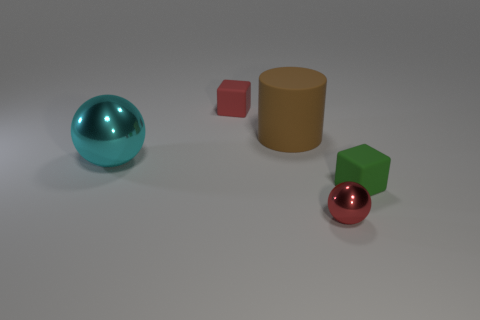Add 2 brown rubber things. How many objects exist? 7 Subtract all blocks. How many objects are left? 3 Subtract 0 red cylinders. How many objects are left? 5 Subtract all matte cylinders. Subtract all tiny red shiny balls. How many objects are left? 3 Add 2 big cyan metallic objects. How many big cyan metallic objects are left? 3 Add 1 tiny yellow cylinders. How many tiny yellow cylinders exist? 1 